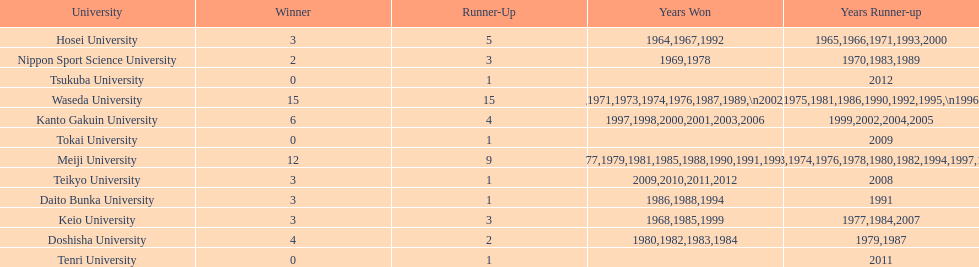Hosei won in 1964. who won the next year? Waseda University. 